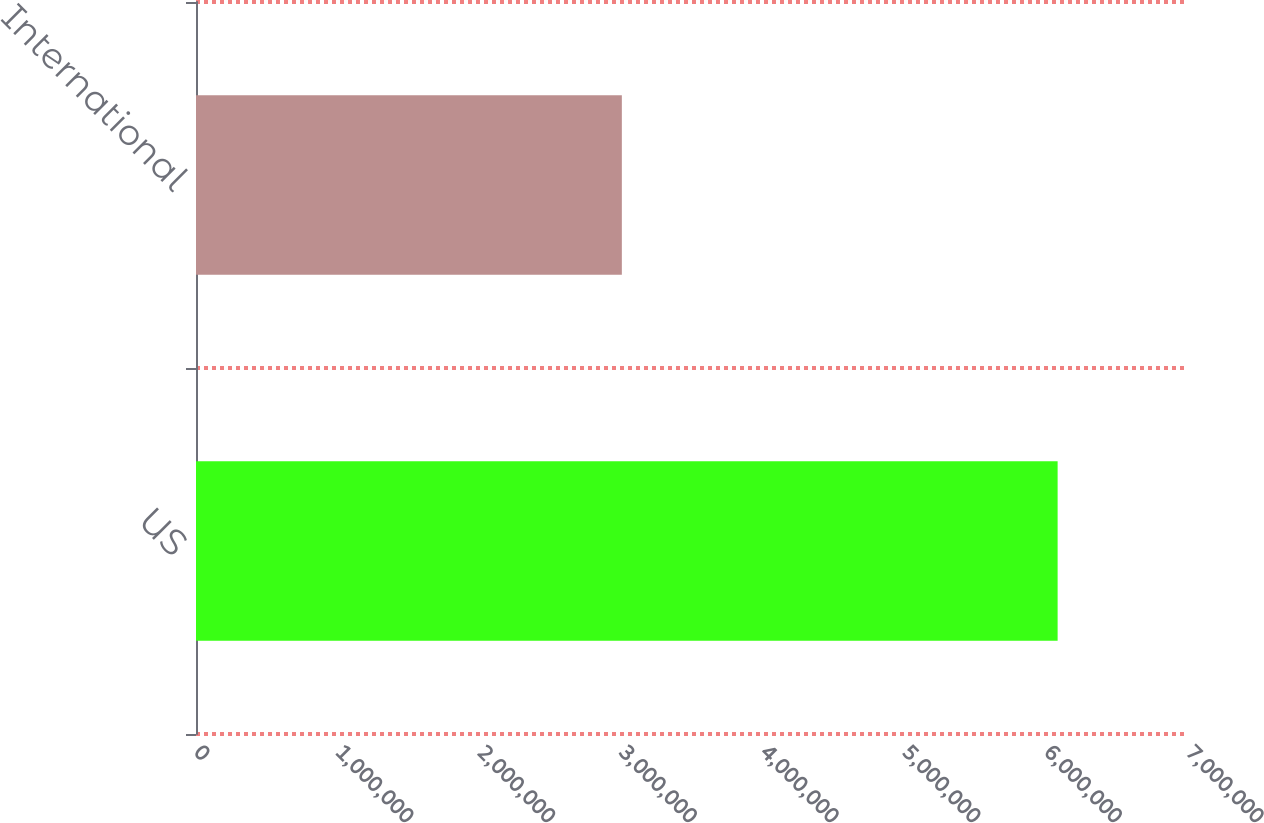<chart> <loc_0><loc_0><loc_500><loc_500><bar_chart><fcel>US<fcel>International<nl><fcel>6.08e+06<fcel>3.005e+06<nl></chart> 